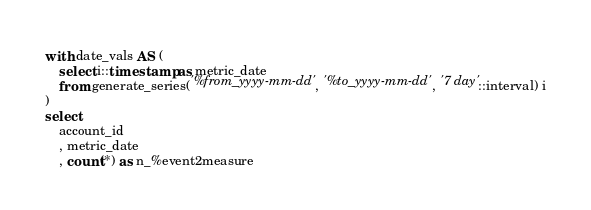Convert code to text. <code><loc_0><loc_0><loc_500><loc_500><_SQL_>with date_vals AS (
  	select i::timestamp as metric_date 
	from generate_series('%from_yyyy-mm-dd', '%to_yyyy-mm-dd', '7 day'::interval) i
)
select 
    account_id
    , metric_date
    , count(*) as n_%event2measure</code> 